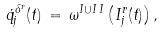Convert formula to latex. <formula><loc_0><loc_0><loc_500><loc_500>\dot { q } _ { j } ^ { \Lambda ^ { r } } ( t ) \, = \, \omega ^ { I \cup I \, I } \left ( I _ { j } ^ { r } ( t ) \right ) ,</formula> 